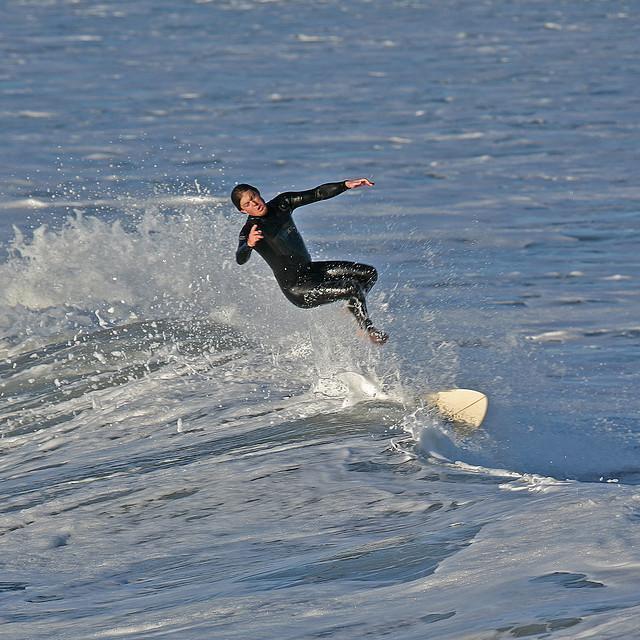How many birds are standing on the sidewalk?
Give a very brief answer. 0. 